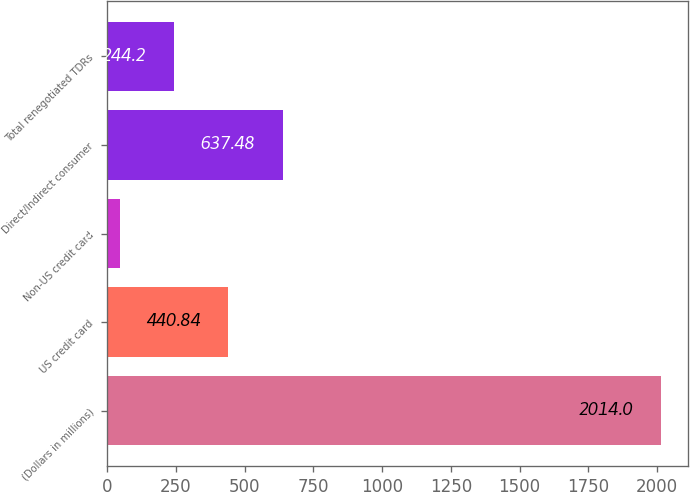Convert chart. <chart><loc_0><loc_0><loc_500><loc_500><bar_chart><fcel>(Dollars in millions)<fcel>US credit card<fcel>Non-US credit card<fcel>Direct/Indirect consumer<fcel>Total renegotiated TDRs<nl><fcel>2014<fcel>440.84<fcel>47.56<fcel>637.48<fcel>244.2<nl></chart> 